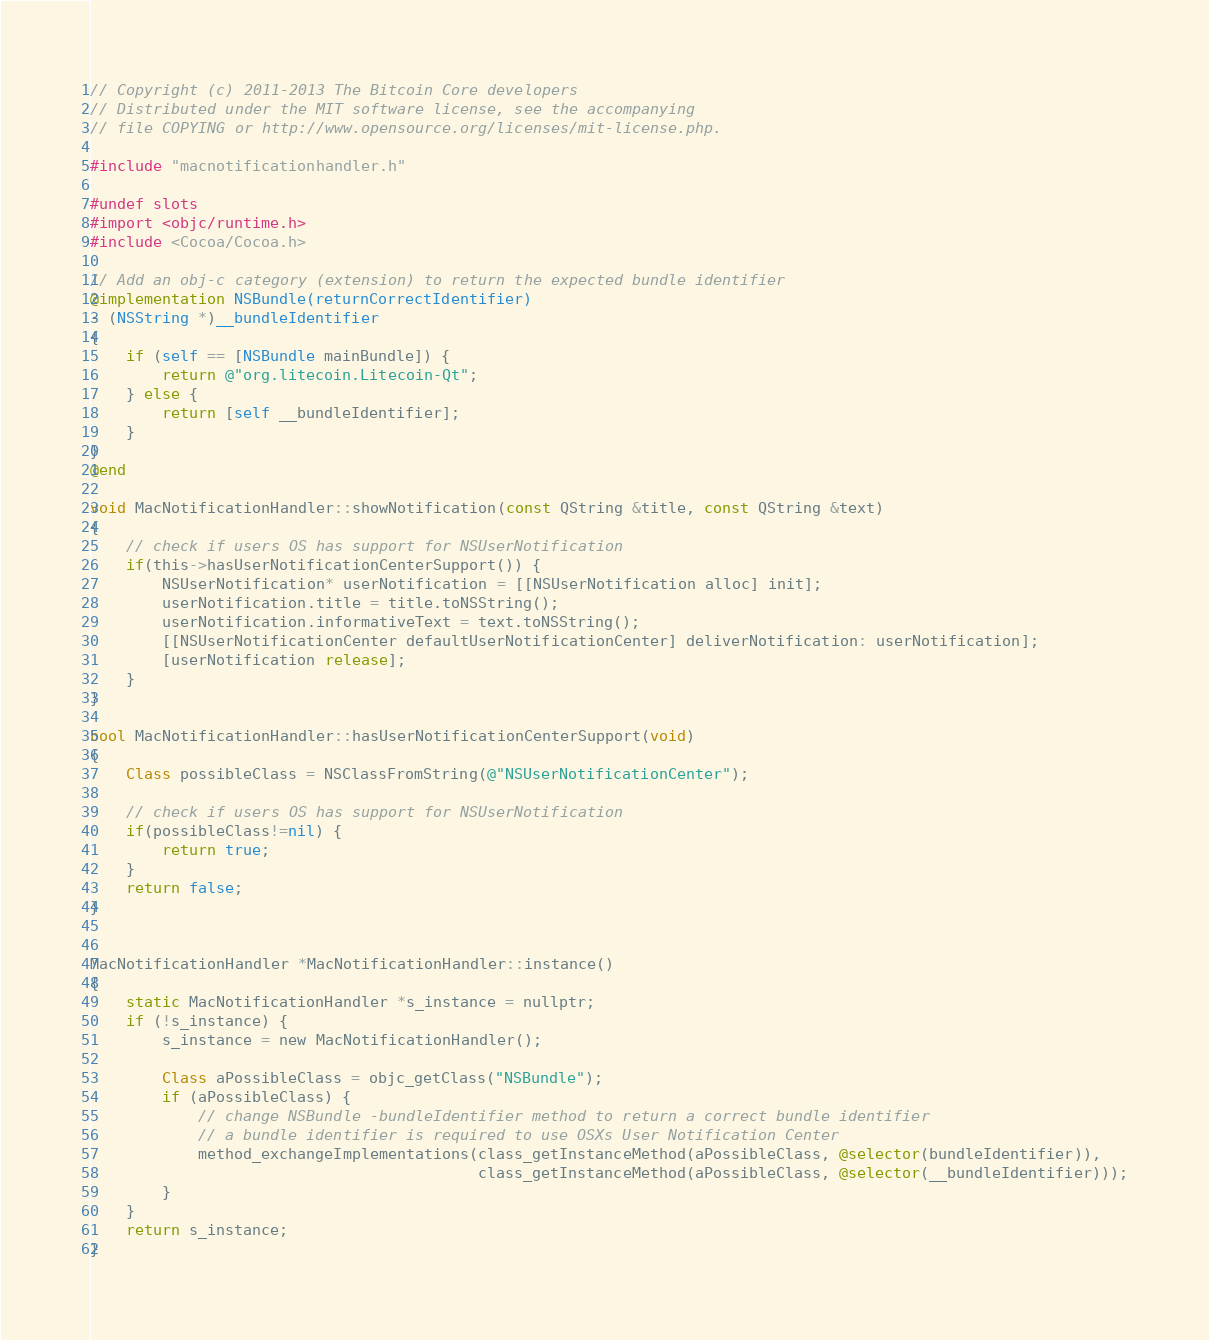Convert code to text. <code><loc_0><loc_0><loc_500><loc_500><_ObjectiveC_>// Copyright (c) 2011-2013 The Bitcoin Core developers
// Distributed under the MIT software license, see the accompanying
// file COPYING or http://www.opensource.org/licenses/mit-license.php.

#include "macnotificationhandler.h"

#undef slots
#import <objc/runtime.h>
#include <Cocoa/Cocoa.h>

// Add an obj-c category (extension) to return the expected bundle identifier
@implementation NSBundle(returnCorrectIdentifier)
- (NSString *)__bundleIdentifier
{
    if (self == [NSBundle mainBundle]) {
        return @"org.litecoin.Litecoin-Qt";
    } else {
        return [self __bundleIdentifier];
    }
}
@end

void MacNotificationHandler::showNotification(const QString &title, const QString &text)
{
    // check if users OS has support for NSUserNotification
    if(this->hasUserNotificationCenterSupport()) {
        NSUserNotification* userNotification = [[NSUserNotification alloc] init];
        userNotification.title = title.toNSString();
        userNotification.informativeText = text.toNSString();
        [[NSUserNotificationCenter defaultUserNotificationCenter] deliverNotification: userNotification];
        [userNotification release];
    }
}

bool MacNotificationHandler::hasUserNotificationCenterSupport(void)
{
    Class possibleClass = NSClassFromString(@"NSUserNotificationCenter");

    // check if users OS has support for NSUserNotification
    if(possibleClass!=nil) {
        return true;
    }
    return false;
}


MacNotificationHandler *MacNotificationHandler::instance()
{
    static MacNotificationHandler *s_instance = nullptr;
    if (!s_instance) {
        s_instance = new MacNotificationHandler();

        Class aPossibleClass = objc_getClass("NSBundle");
        if (aPossibleClass) {
            // change NSBundle -bundleIdentifier method to return a correct bundle identifier
            // a bundle identifier is required to use OSXs User Notification Center
            method_exchangeImplementations(class_getInstanceMethod(aPossibleClass, @selector(bundleIdentifier)),
                                           class_getInstanceMethod(aPossibleClass, @selector(__bundleIdentifier)));
        }
    }
    return s_instance;
}
</code> 